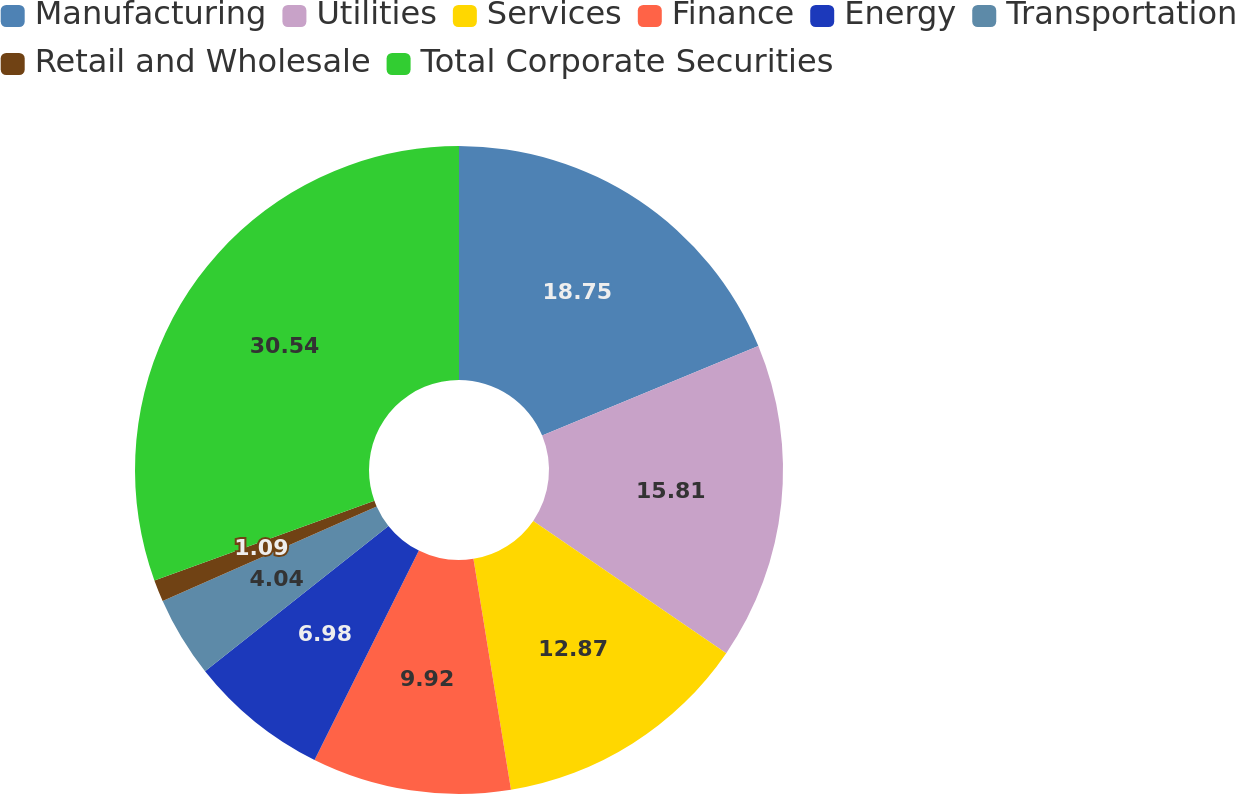Convert chart to OTSL. <chart><loc_0><loc_0><loc_500><loc_500><pie_chart><fcel>Manufacturing<fcel>Utilities<fcel>Services<fcel>Finance<fcel>Energy<fcel>Transportation<fcel>Retail and Wholesale<fcel>Total Corporate Securities<nl><fcel>18.75%<fcel>15.81%<fcel>12.87%<fcel>9.92%<fcel>6.98%<fcel>4.04%<fcel>1.09%<fcel>30.53%<nl></chart> 